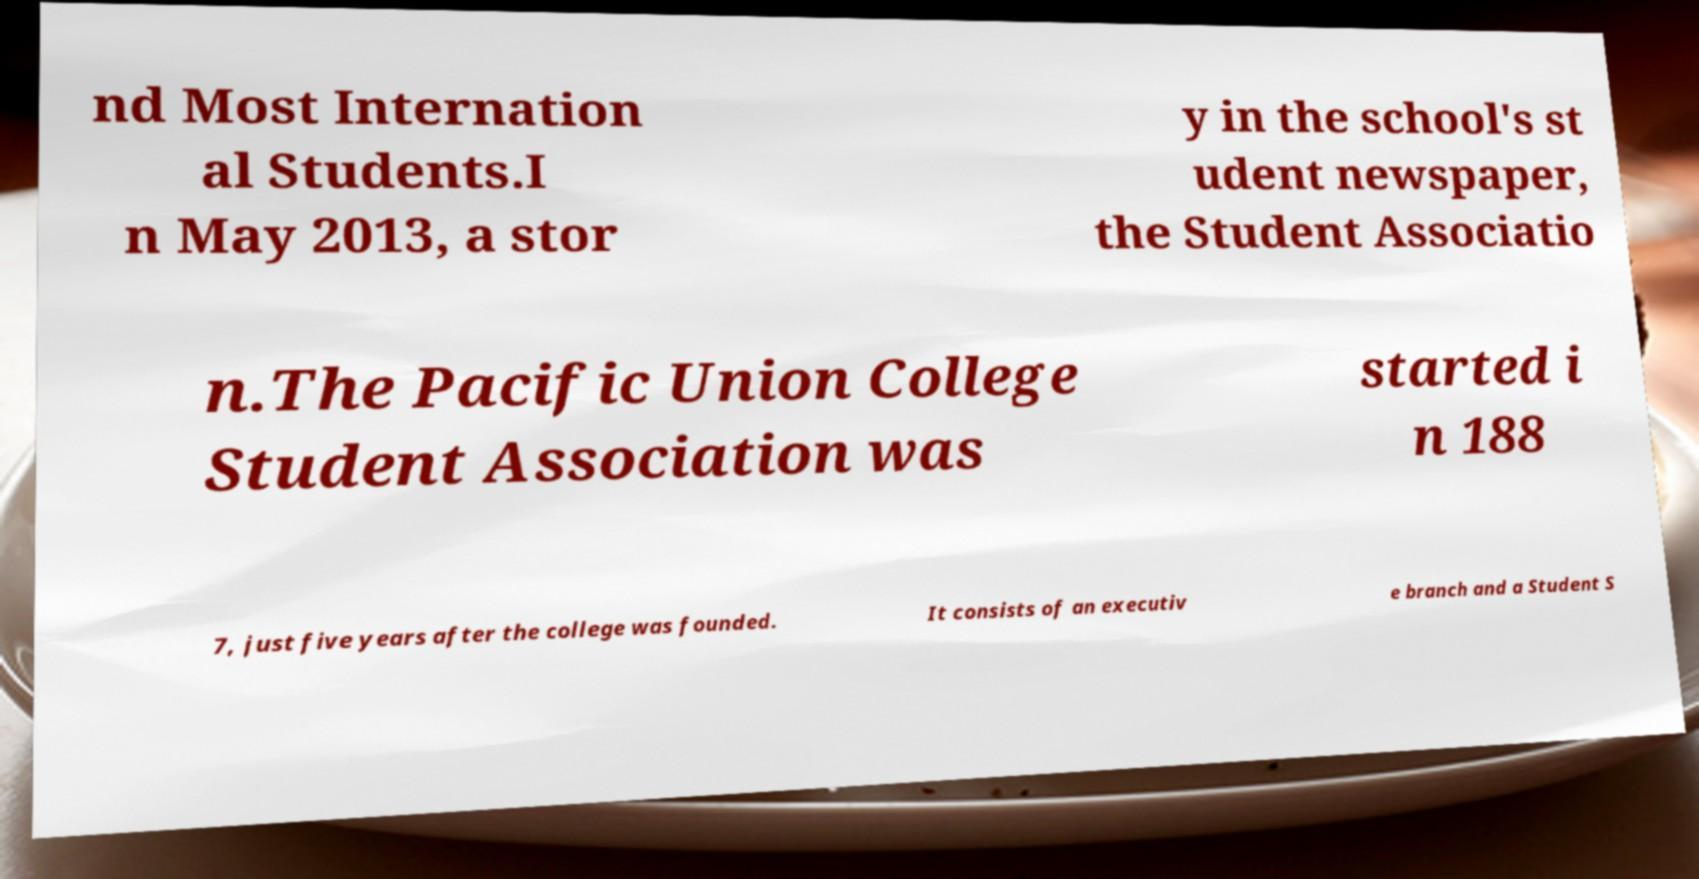I need the written content from this picture converted into text. Can you do that? nd Most Internation al Students.I n May 2013, a stor y in the school's st udent newspaper, the Student Associatio n.The Pacific Union College Student Association was started i n 188 7, just five years after the college was founded. It consists of an executiv e branch and a Student S 